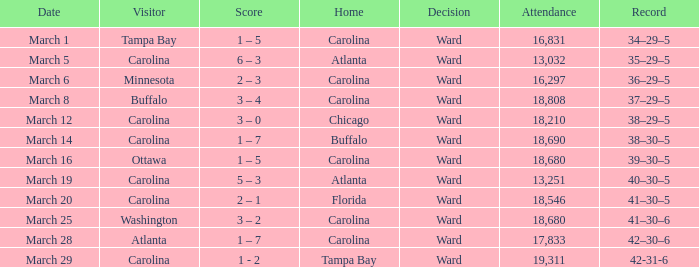What is the score when buffalo is at home? 38–30–5. 